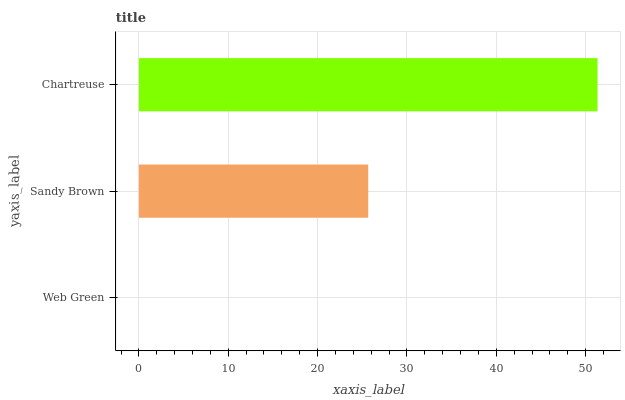Is Web Green the minimum?
Answer yes or no. Yes. Is Chartreuse the maximum?
Answer yes or no. Yes. Is Sandy Brown the minimum?
Answer yes or no. No. Is Sandy Brown the maximum?
Answer yes or no. No. Is Sandy Brown greater than Web Green?
Answer yes or no. Yes. Is Web Green less than Sandy Brown?
Answer yes or no. Yes. Is Web Green greater than Sandy Brown?
Answer yes or no. No. Is Sandy Brown less than Web Green?
Answer yes or no. No. Is Sandy Brown the high median?
Answer yes or no. Yes. Is Sandy Brown the low median?
Answer yes or no. Yes. Is Chartreuse the high median?
Answer yes or no. No. Is Web Green the low median?
Answer yes or no. No. 